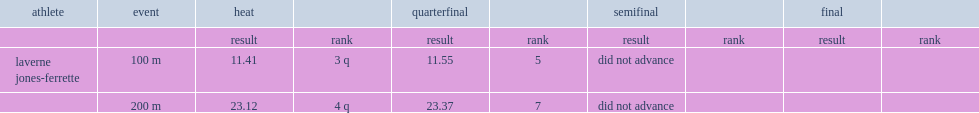I'm looking to parse the entire table for insights. Could you assist me with that? {'header': ['athlete', 'event', 'heat', '', 'quarterfinal', '', 'semifinal', '', 'final', ''], 'rows': [['', '', 'result', 'rank', 'result', 'rank', 'result', 'rank', 'result', 'rank'], ['laverne jones-ferrette', '100 m', '11.41', '3 q', '11.55', '5', 'did not advance', '', '', ''], ['', '200 m', '23.12', '4 q', '23.37', '7', 'did not advance', '', '', '']]} What was the result that laverne jones-ferrette got in the heat in 100m event? 11.41. 